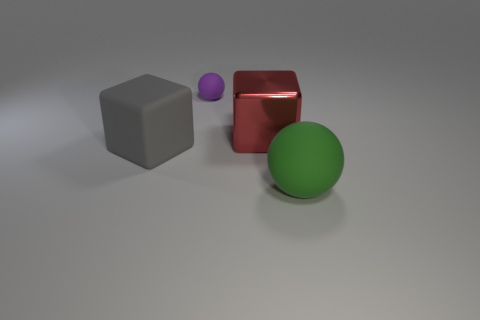Is there anything else that has the same size as the purple matte object?
Ensure brevity in your answer.  No. The thing that is left of the red shiny thing and in front of the tiny purple ball has what shape?
Keep it short and to the point. Cube. Is the number of rubber balls to the left of the red block greater than the number of cylinders?
Offer a very short reply. Yes. The purple thing that is made of the same material as the large green sphere is what size?
Give a very brief answer. Small. Is the number of small purple spheres that are to the right of the green matte sphere the same as the number of matte spheres in front of the small purple matte thing?
Make the answer very short. No. Is there anything else that is made of the same material as the big red cube?
Offer a very short reply. No. What is the color of the matte thing to the right of the red cube?
Offer a very short reply. Green. Are there the same number of matte things behind the red block and yellow metallic objects?
Ensure brevity in your answer.  No. What number of other things are there of the same shape as the purple object?
Keep it short and to the point. 1. There is a tiny purple matte ball; how many tiny matte objects are right of it?
Your answer should be compact. 0. 